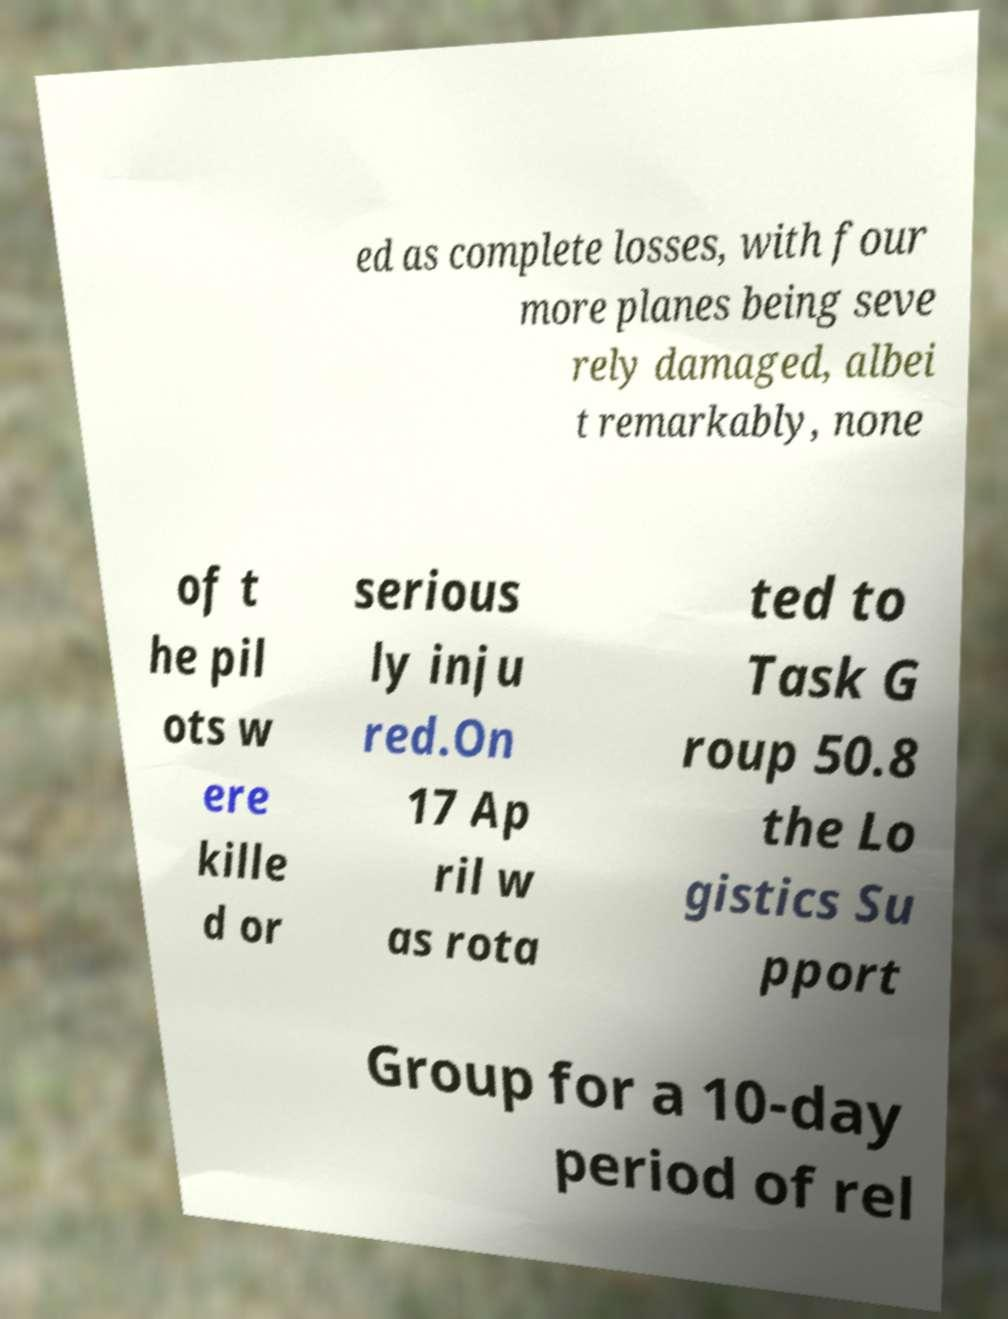Please identify and transcribe the text found in this image. ed as complete losses, with four more planes being seve rely damaged, albei t remarkably, none of t he pil ots w ere kille d or serious ly inju red.On 17 Ap ril w as rota ted to Task G roup 50.8 the Lo gistics Su pport Group for a 10-day period of rel 